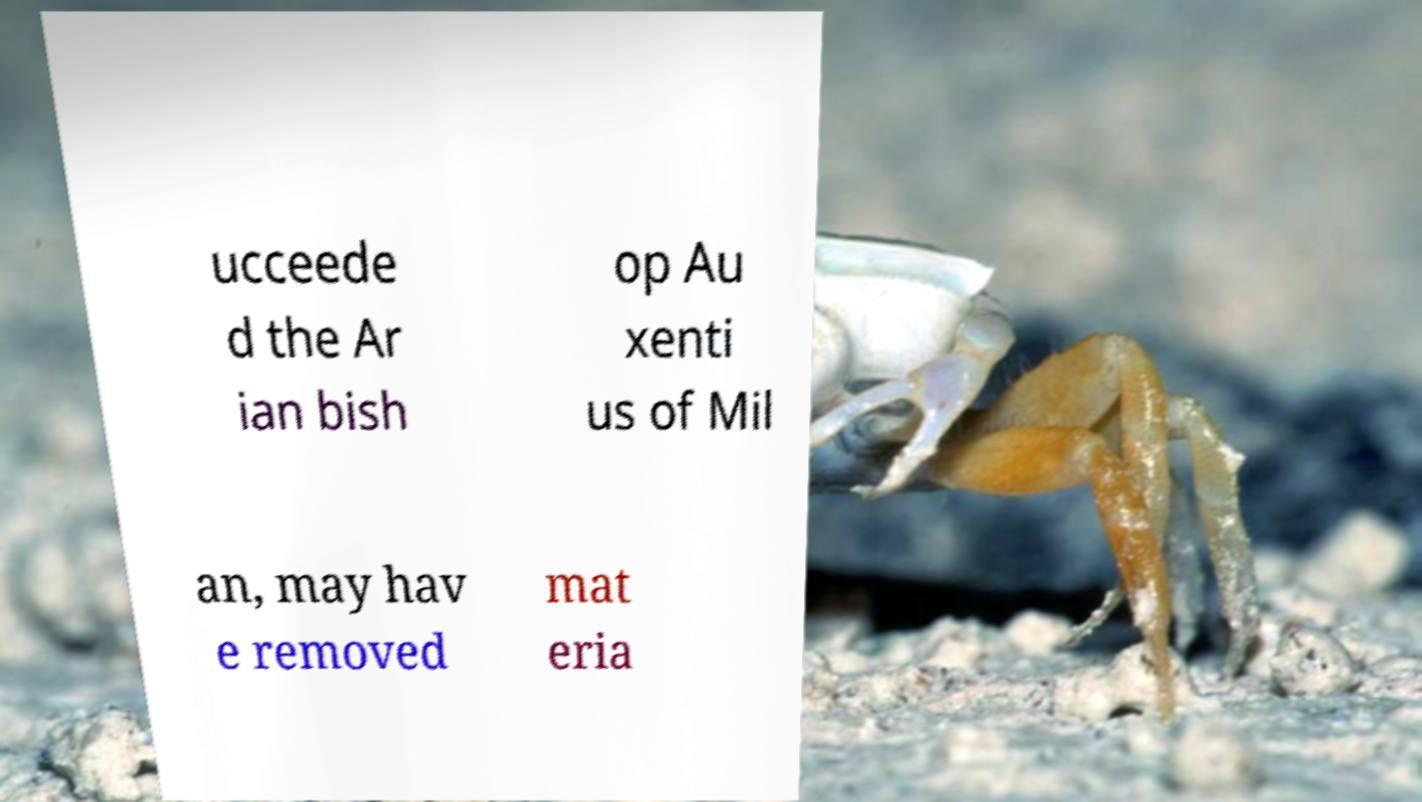Please read and relay the text visible in this image. What does it say? ucceede d the Ar ian bish op Au xenti us of Mil an, may hav e removed mat eria 